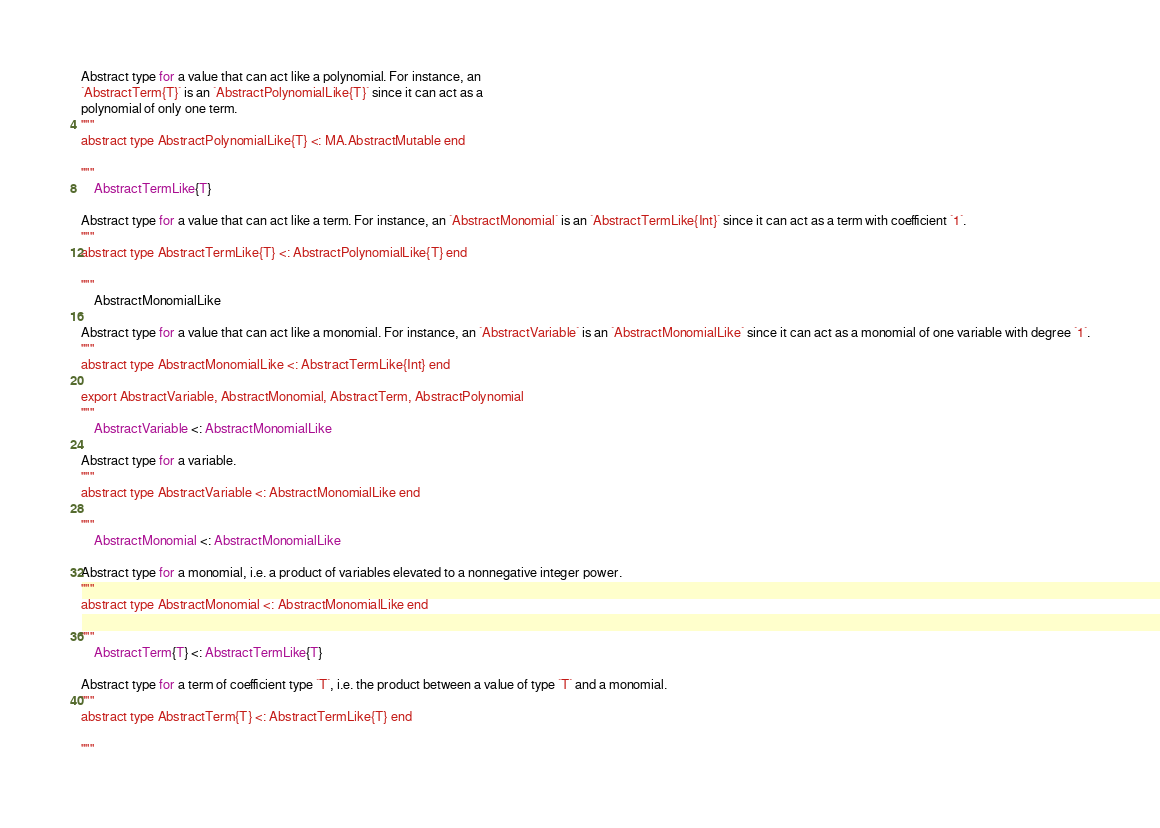<code> <loc_0><loc_0><loc_500><loc_500><_Julia_>
Abstract type for a value that can act like a polynomial. For instance, an
`AbstractTerm{T}` is an `AbstractPolynomialLike{T}` since it can act as a
polynomial of only one term.
"""
abstract type AbstractPolynomialLike{T} <: MA.AbstractMutable end

"""
    AbstractTermLike{T}

Abstract type for a value that can act like a term. For instance, an `AbstractMonomial` is an `AbstractTermLike{Int}` since it can act as a term with coefficient `1`.
"""
abstract type AbstractTermLike{T} <: AbstractPolynomialLike{T} end

"""
    AbstractMonomialLike

Abstract type for a value that can act like a monomial. For instance, an `AbstractVariable` is an `AbstractMonomialLike` since it can act as a monomial of one variable with degree `1`.
"""
abstract type AbstractMonomialLike <: AbstractTermLike{Int} end

export AbstractVariable, AbstractMonomial, AbstractTerm, AbstractPolynomial
"""
    AbstractVariable <: AbstractMonomialLike

Abstract type for a variable.
"""
abstract type AbstractVariable <: AbstractMonomialLike end

"""
    AbstractMonomial <: AbstractMonomialLike

Abstract type for a monomial, i.e. a product of variables elevated to a nonnegative integer power.
"""
abstract type AbstractMonomial <: AbstractMonomialLike end

"""
    AbstractTerm{T} <: AbstractTermLike{T}

Abstract type for a term of coefficient type `T`, i.e. the product between a value of type `T` and a monomial.
"""
abstract type AbstractTerm{T} <: AbstractTermLike{T} end

"""</code> 